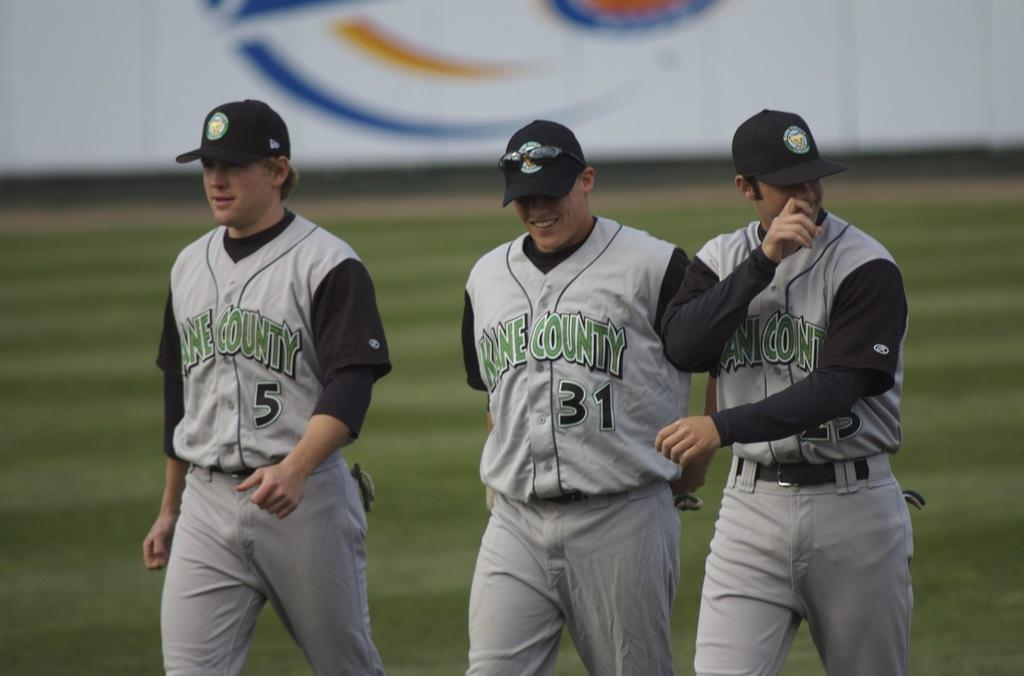<image>
Present a compact description of the photo's key features. Baseball player number 31 is flanked by two teammates. 